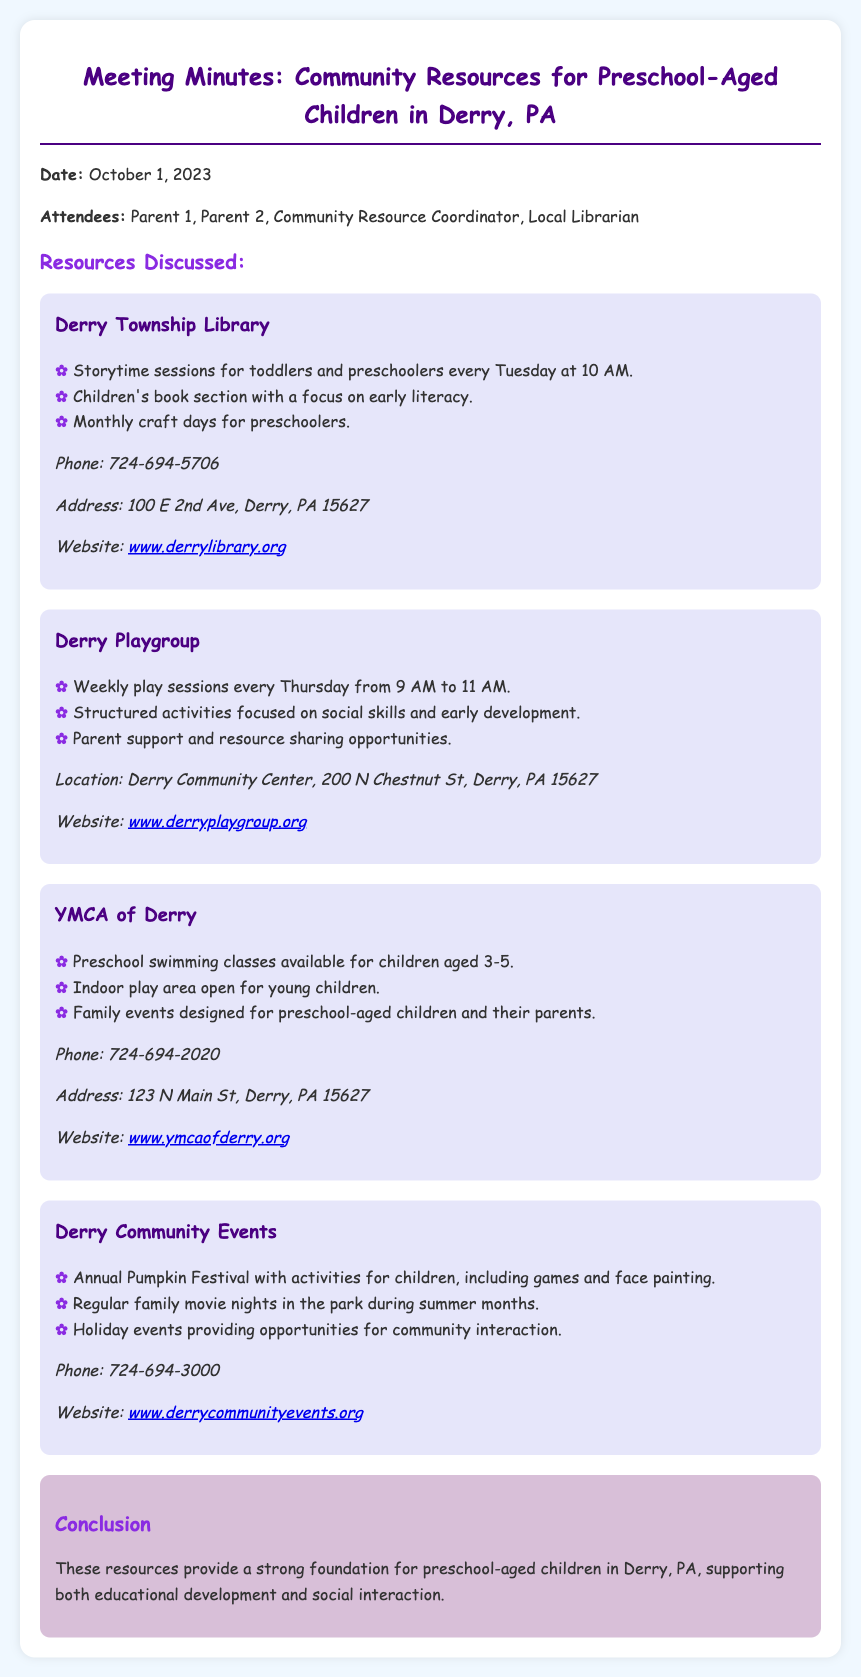What day and time does the Derry Township Library hold storytime sessions? The document states that storytime sessions are held every Tuesday at 10 AM.
Answer: Tuesday at 10 AM What age range is targeted by the preschool swimming classes at YMCA of Derry? The document specifies that these classes are for children aged 3-5.
Answer: 3-5 How often does the Derry Playgroup meet? The document mentions that the playgroup meets weekly on Thursdays.
Answer: Weekly What is an activity mentioned that takes place during the annual Pumpkin Festival? The document lists games and face painting as activities for children during the festival.
Answer: Games and face painting Which library resource focuses on early literacy? The document indicates the Children's book section as a resource that focuses on early literacy.
Answer: Children's book section How many attendees were at the meeting? The document provides a list of four attendees present during the meeting.
Answer: Four What is the primary purpose of the Derry Playgroup's structured activities? The document states that the structured activities focus on social skills and early development.
Answer: Social skills and early development What month does the family movie nights occur in the park? The document refers to family movie nights happening during summer months.
Answer: Summer months 